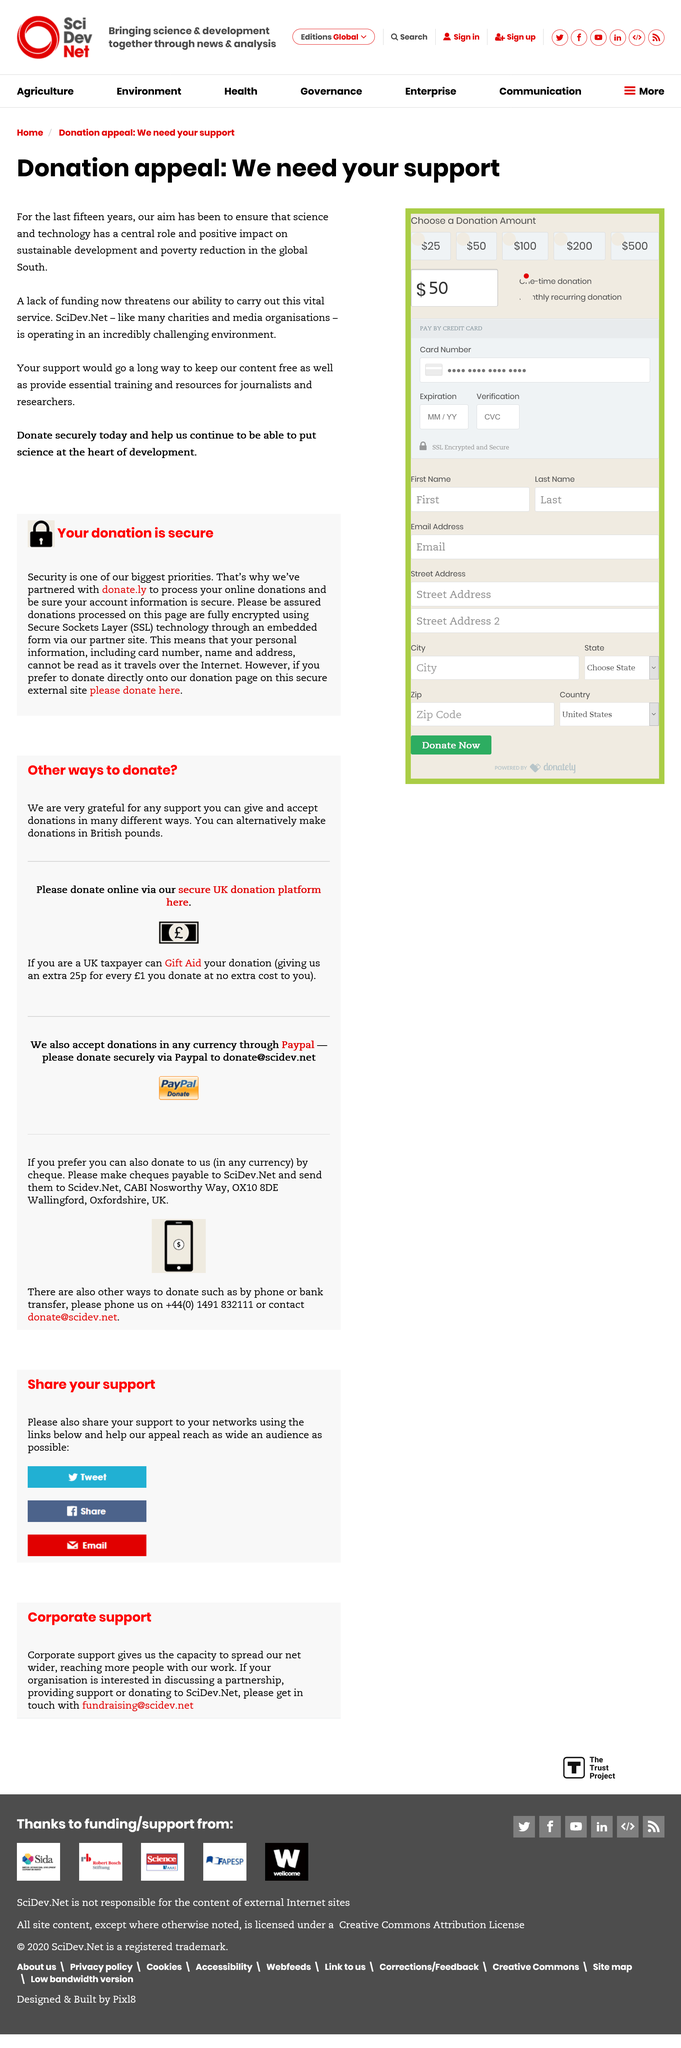Highlight a few significant elements in this photo. You can help keep the content on this site free by donating to it. The issue with current services is the lack of funding. The company has been providing resources for the past 15 years. 